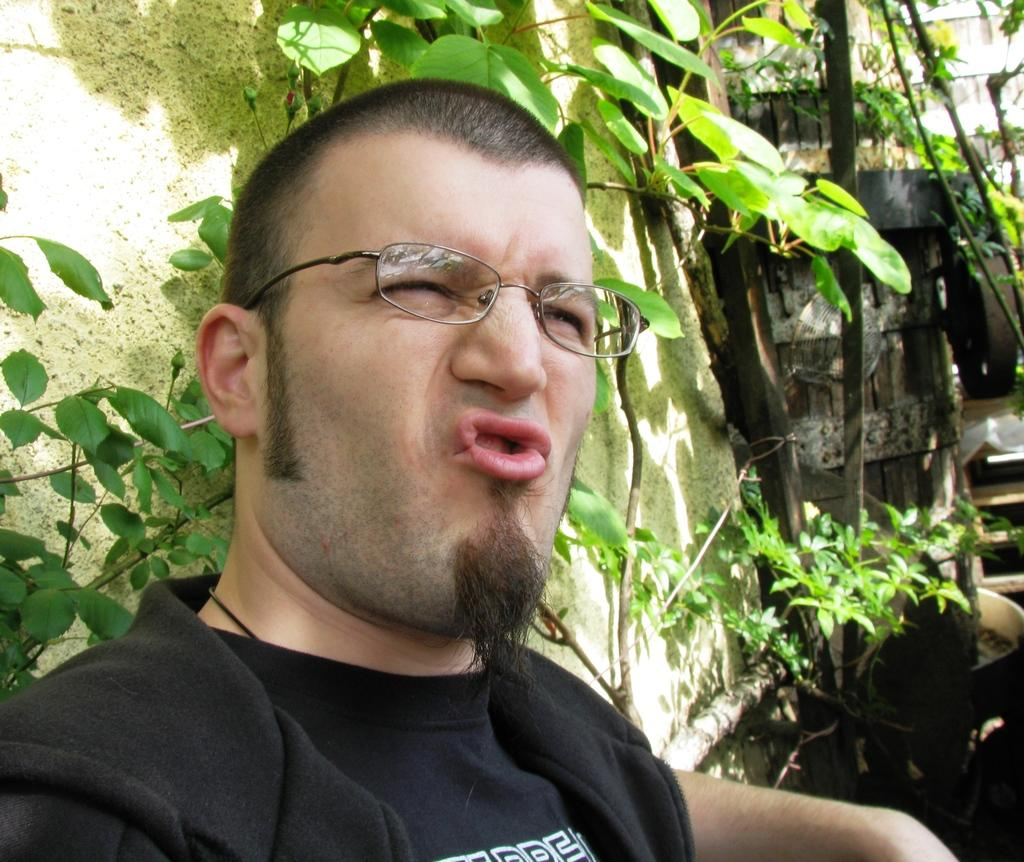What is the main subject of the picture? The main subject of the picture is a man. Can you describe the man's appearance? The man is wearing spectacles and a black t-shirt. Where is the man located in the image? The man is standing near a wall. What can be seen on the right side of the image? There are trees, plants, and wooden tables on the right side of the image. Can you hear the man whistling in the image? There is no indication of sound or whistling in the image, as it is a still photograph. What type of reaction does the bat have to the man in the image? There is no bat present in the image, so it is not possible to determine any reaction. 